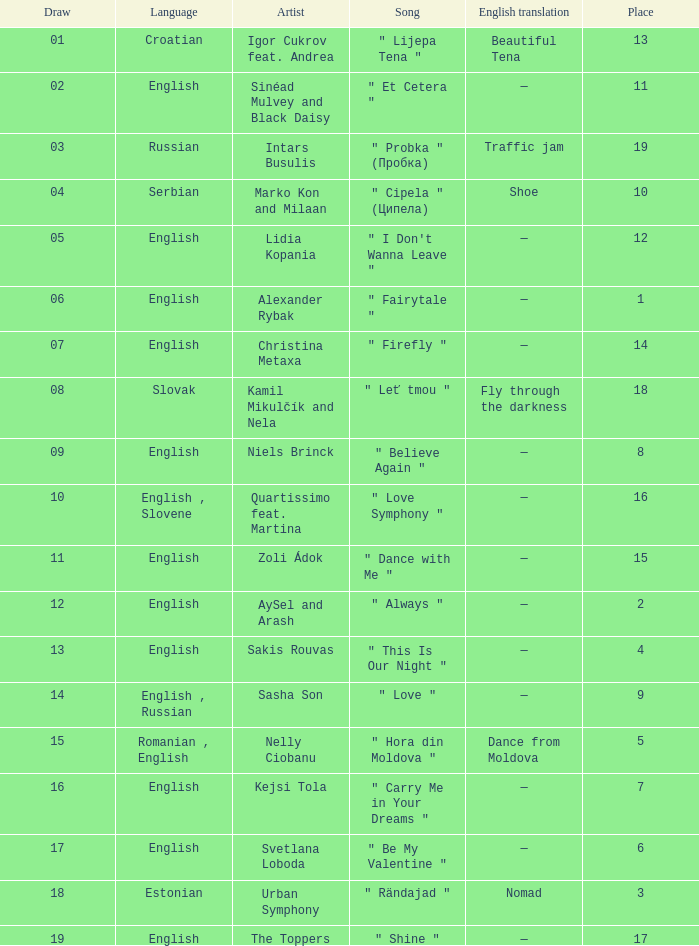What is the english translation when the language is english, draw is smaller than 16, and the artist is aysel and arash? —. 